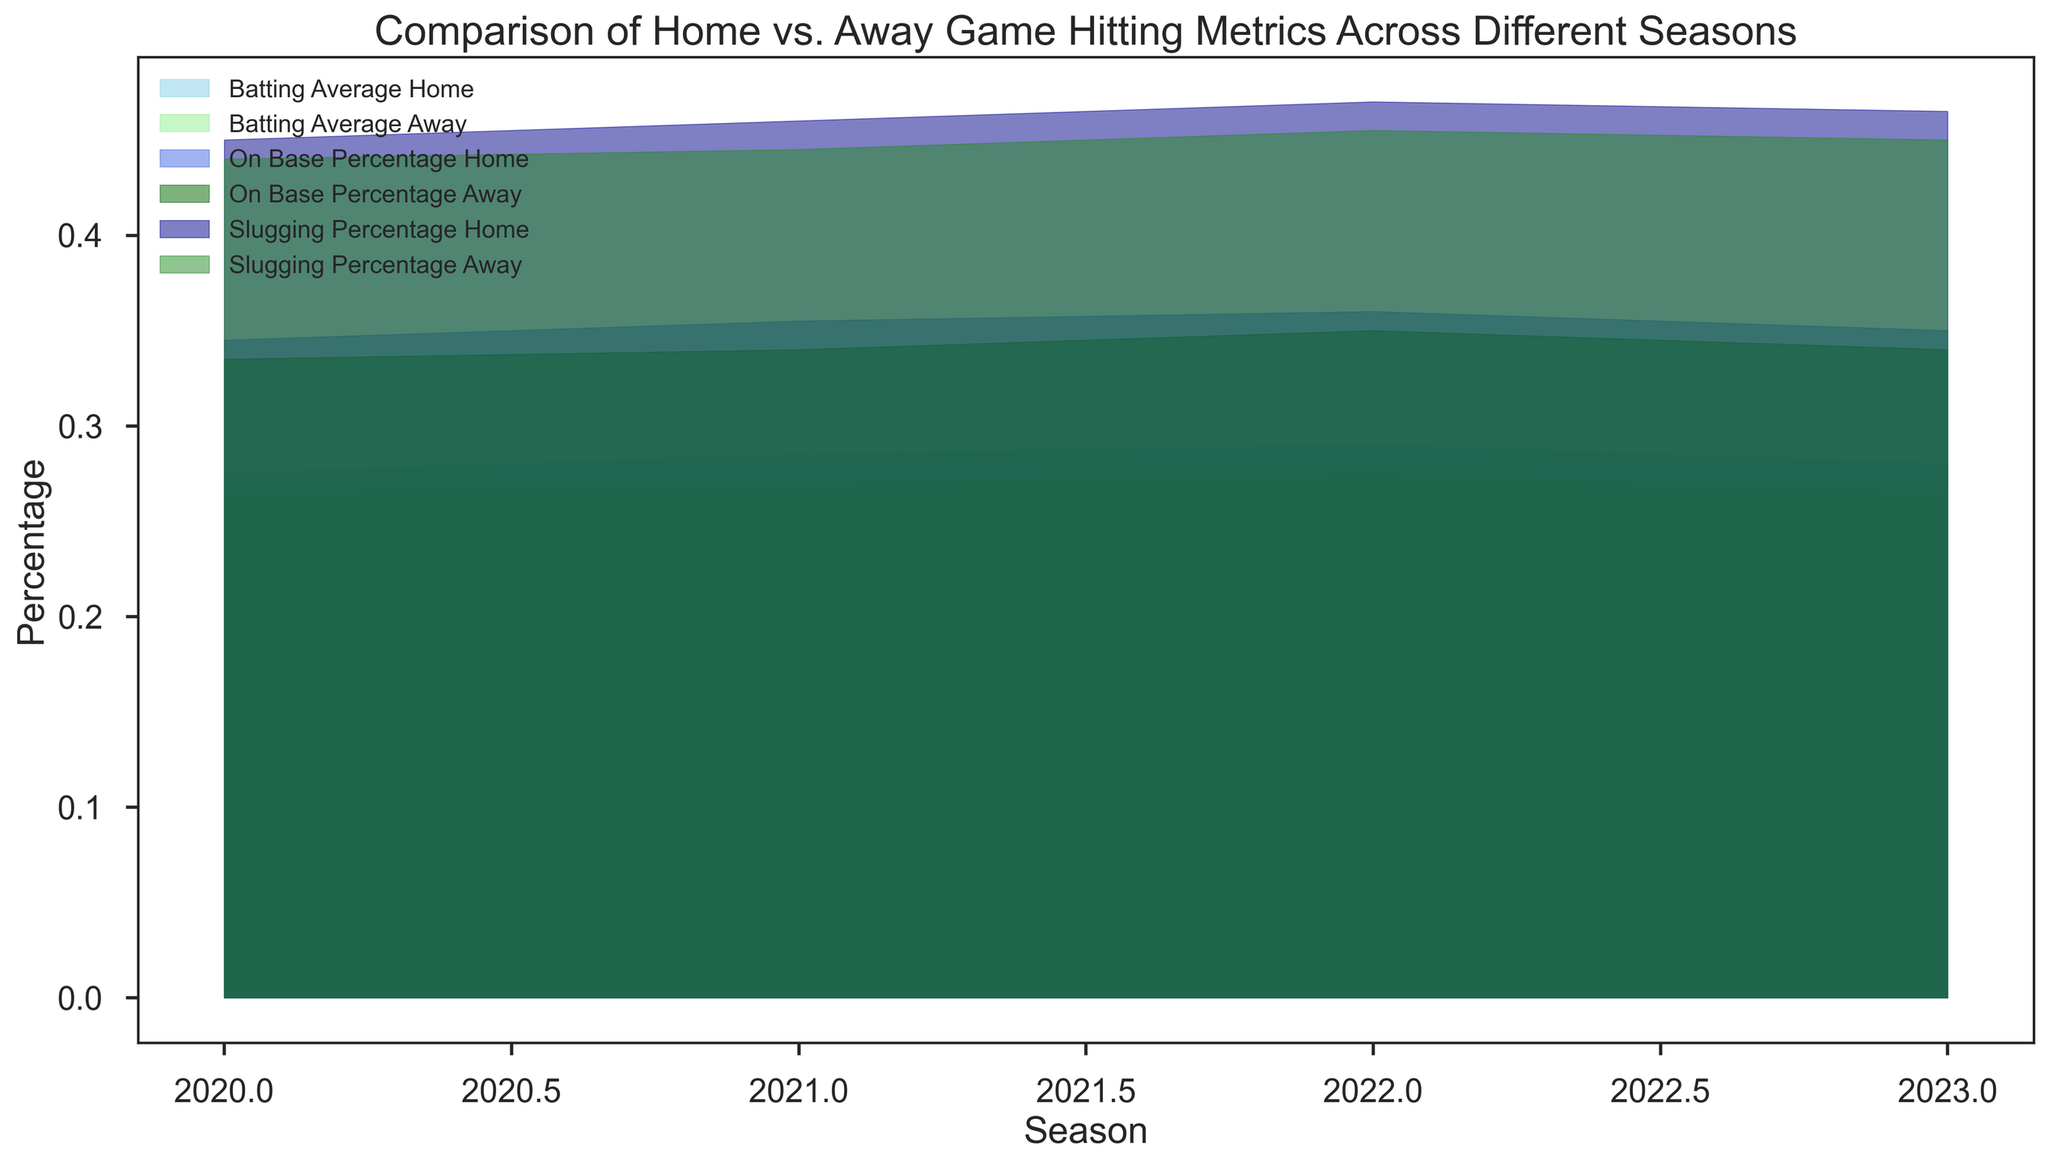What's the difference in Batting Average between Home and Away games in 2022? In the figure, to find the difference in Batting Average between Home and Away games in 2022, we subtract the Away value (0.275) from the Home value (0.290).
Answer: 0.015 Which season shows the highest On Base Percentage for Home games? By visually comparing each season's On Base Percentage for Home games, 2022 has the highest On Base Percentage, which is evident as it reaches the highest point visually on the chart.
Answer: 2022 Are there any seasons where the Slugging Percentage for Away games is higher than that for Home games? By visually comparing the Slugging Percentage for Home and Away games across all seasons, there is no season where the Slugging Percentage for Away games exceeds that for Home games. Thus, the Away lines are always under the Home lines.
Answer: No In which season is the difference between Home and Away On Base Percentage the smallest? We need to visually approximate the difference between Home and Away On Base Percentage for each season and determine the smallest gap. For 2023, the difference seems minimal at approximately 0.010.
Answer: 2023 What trend can be observed in Batting Average for Away games from 2020 to 2023? By tracking the Batting Average for Away games using the different colors in the chart, we observe a general fluctuation: starting slightly higher in 2020 (0.265), dipping in 2021 (0.270), peaking in 2022 (0.275), and finally decreasing slightly in 2023 (0.265).
Answer: It fluctuates up and down Does the Slugging Percentage for Home games show an increasing, decreasing, or mixed trend from 2020 to 2023? By analyzing the Slugging Percentage for Home games, we observe an increasing trend from 0.450 in 2020 to 0.470 in 2022, then a slight decrease to 0.465 in 2023, indicating a mostly increasing, but somewhat mixed trend.
Answer: Mixed, mostly increasing How much higher is the Slugging Percentage for Home games than Away games in 2021? By checking the figure, the Slugging Percentage for Home games in 2021 is 0.460 and for Away games is 0.445. Subtracting the Away value from the Home value gives 0.015.
Answer: 0.015 What is the visual comparison between the Batting Average for Home games and the On Base Percentage for Away games in 2021? Comparatively, the Batting Average for Home games in 2021 (0.285) is visually lower than the On Base Percentage for Away games in 2021 (0.340). The colors and levels on the chart clearly show the difference.
Answer: Batting Average Home is lower Which game type generally shows higher hitting metrics (average, on-base, slugging) across the seasons? By visually inspecting the hitting metrics (Batting Average, On Base Percentage, Slugging Percentage) across the seasons, Home games generally show higher values compared to Away games. This is consistent across various metrics and through multiple seasons.
Answer: Home games 